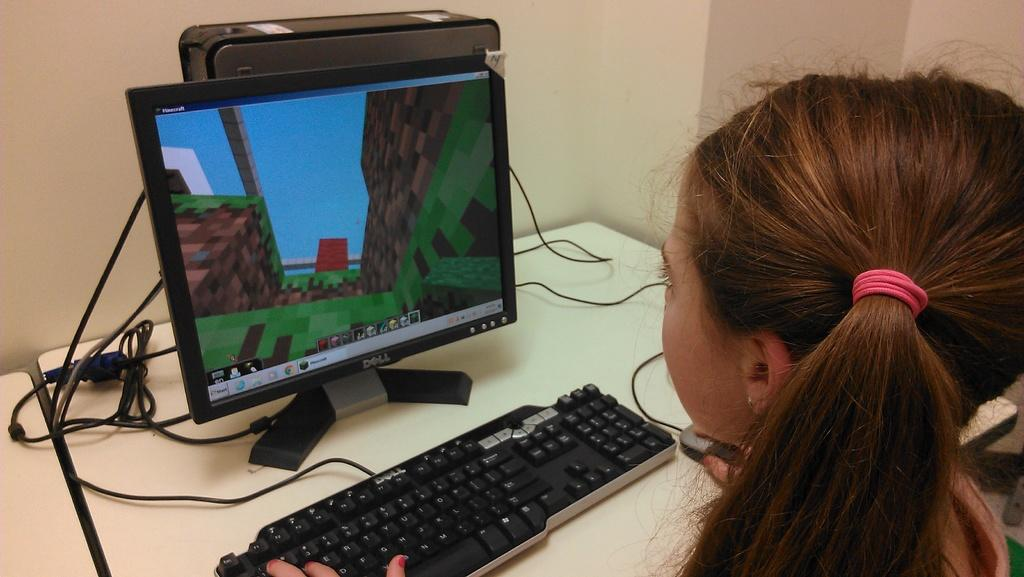Provide a one-sentence caption for the provided image. A girl playing a game on a Dell computer. 